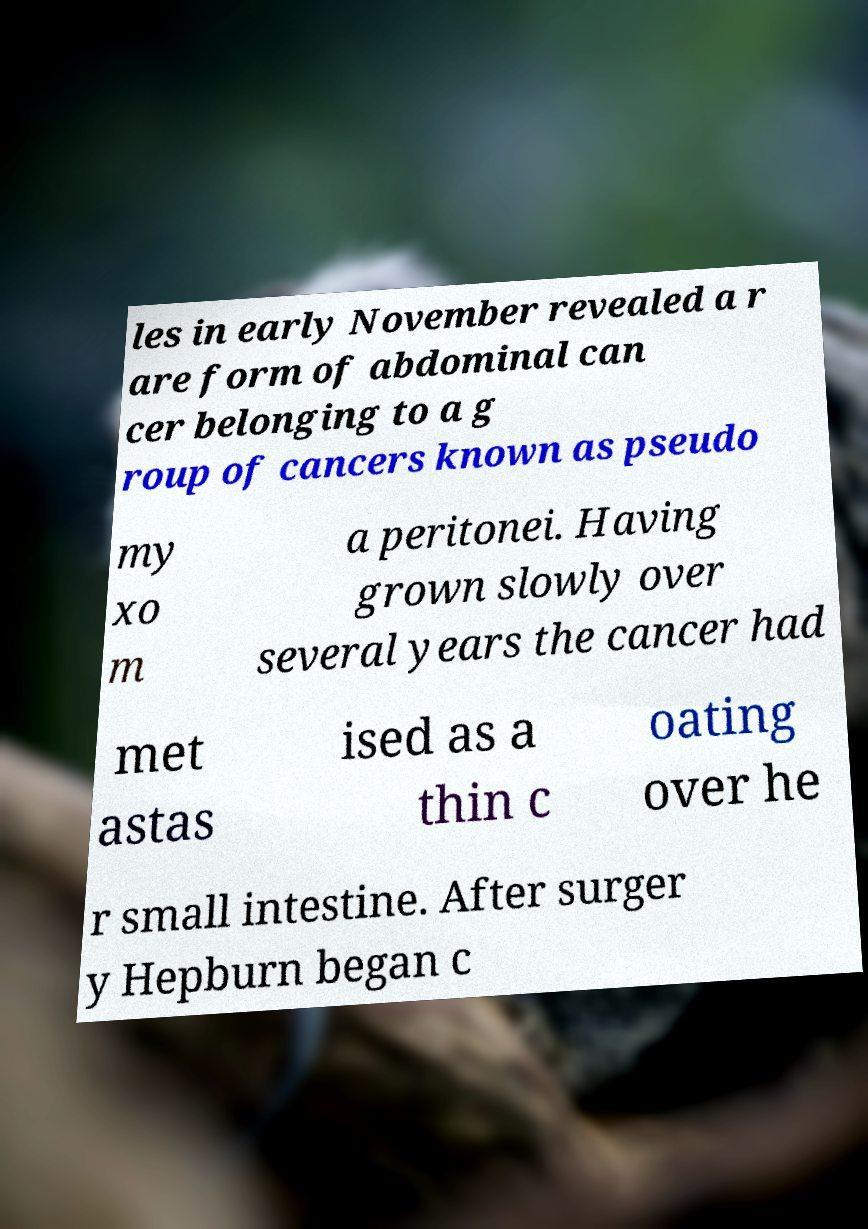Can you read and provide the text displayed in the image?This photo seems to have some interesting text. Can you extract and type it out for me? les in early November revealed a r are form of abdominal can cer belonging to a g roup of cancers known as pseudo my xo m a peritonei. Having grown slowly over several years the cancer had met astas ised as a thin c oating over he r small intestine. After surger y Hepburn began c 